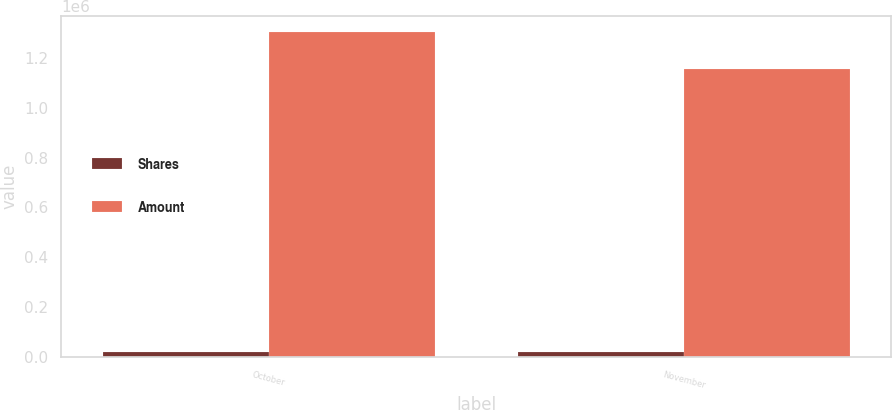Convert chart to OTSL. <chart><loc_0><loc_0><loc_500><loc_500><stacked_bar_chart><ecel><fcel>October<fcel>November<nl><fcel>Shares<fcel>20565<fcel>18573<nl><fcel>Amount<fcel>1.30259e+06<fcel>1.15458e+06<nl></chart> 